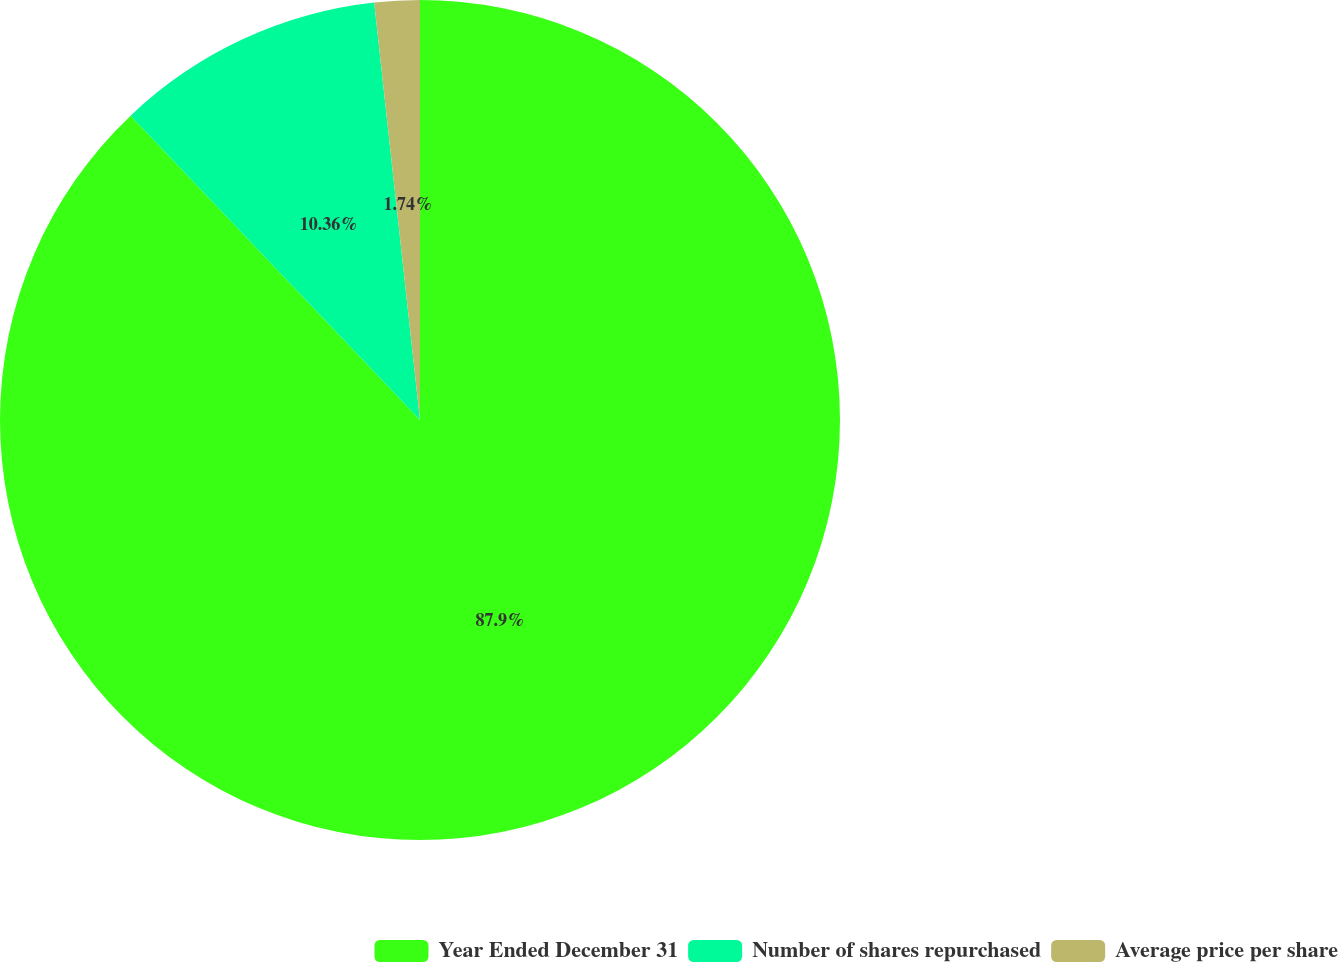Convert chart to OTSL. <chart><loc_0><loc_0><loc_500><loc_500><pie_chart><fcel>Year Ended December 31<fcel>Number of shares repurchased<fcel>Average price per share<nl><fcel>87.9%<fcel>10.36%<fcel>1.74%<nl></chart> 